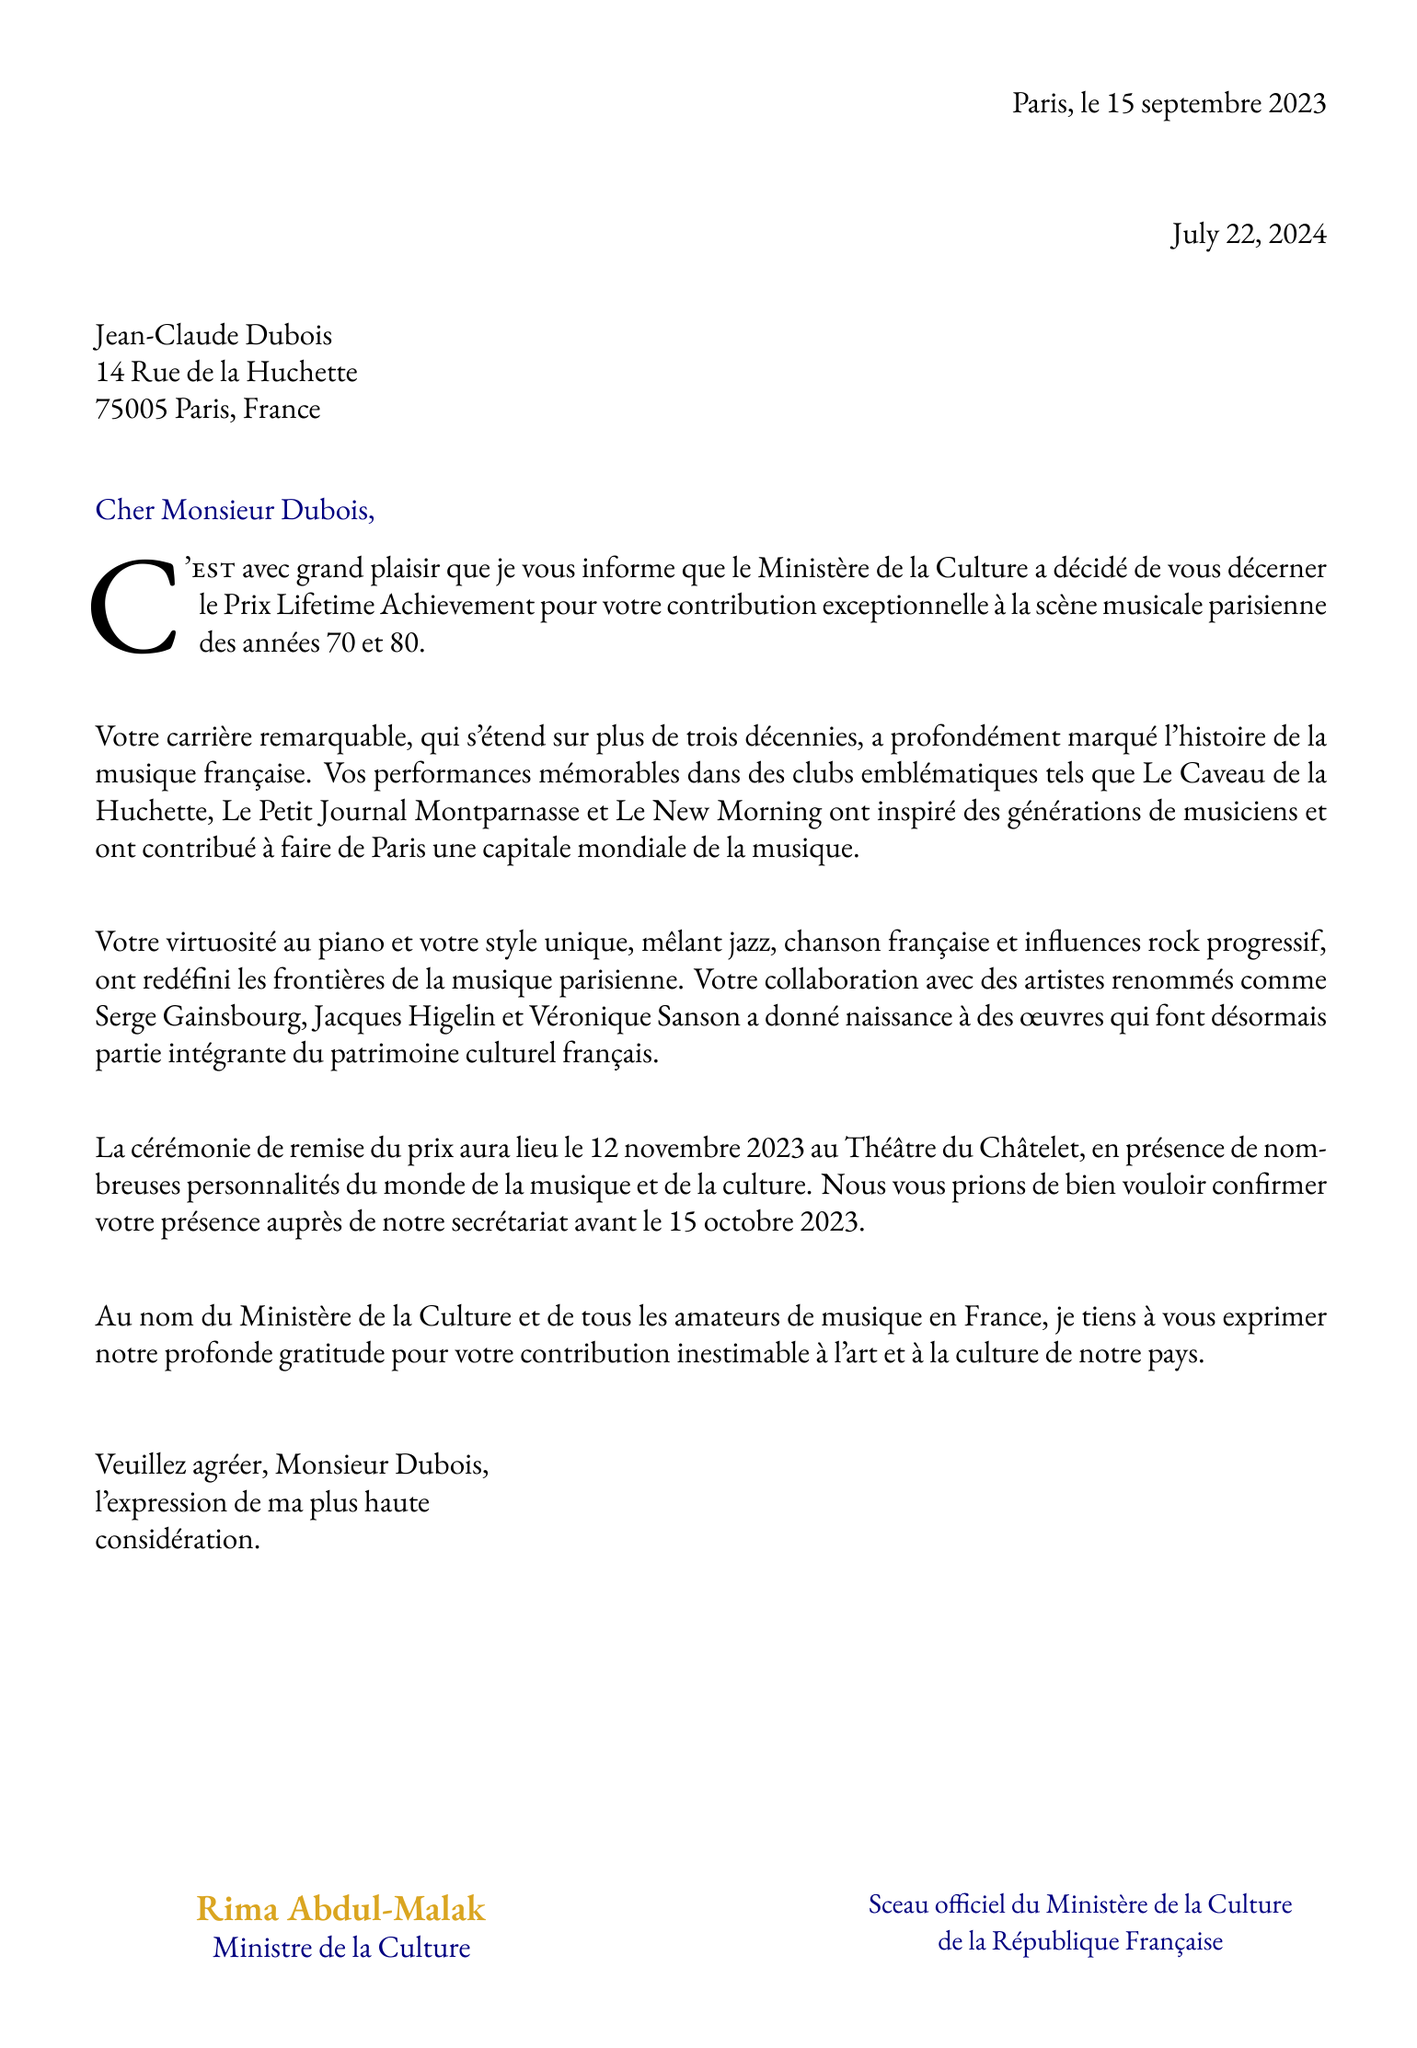What is the date of the letter? The date is specified in the letter as "15 septembre 2023."
Answer: 15 septembre 2023 Who is the recipient of the letter? The letter addresses "Jean-Claude Dubois" as the recipient.
Answer: Jean-Claude Dubois What award is mentioned in the letter? The letter announces a "Prix Lifetime Achievement" award for contributions to music.
Answer: Prix Lifetime Achievement Where will the award ceremony take place? The letter states that the ceremony will be held at "Théâtre du Châtelet."
Answer: Théâtre du Châtelet What style of music did Jean-Claude Dubois uniquely blend? The letter describes his style as a blend of "jazz, chanson française et influences rock progressif."
Answer: jazz, chanson française et influences rock progressif Who signed the letter? The letter is signed by "Rima Abdul-Malak."
Answer: Rima Abdul-Malak What is the official seal mentioned in the letter? The letter refers to "Sceau officiel du Ministère de la Culture de la République Française."
Answer: Sceau officiel du Ministère de la Culture de la République Française By when must the recipient confirm attendance? The letter states that confirmation is needed before "15 octobre 2023."
Answer: 15 octobre 2023 